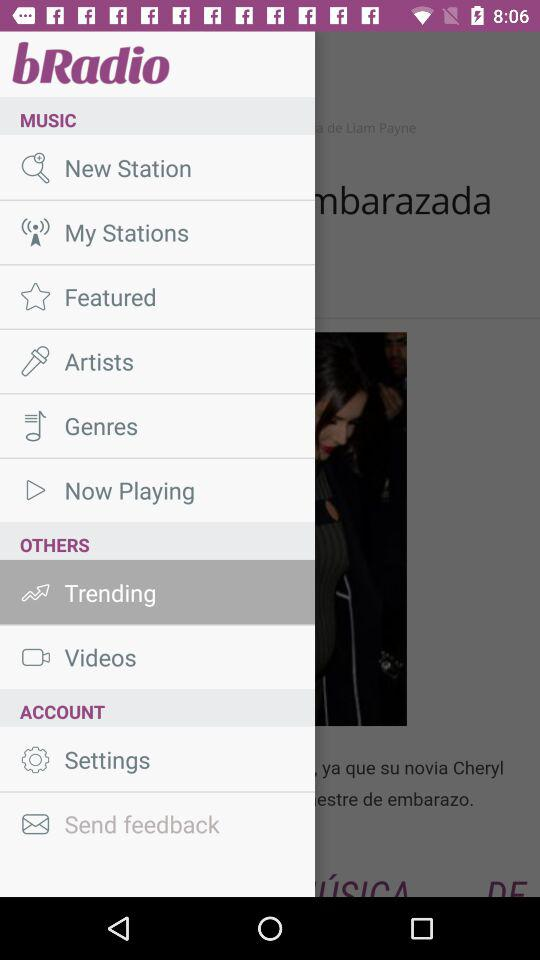What is the application name? The application name is "bRadio". 